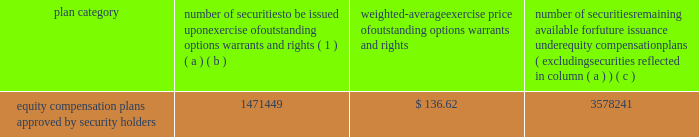Part a0iii item a010 .
Directors , executive officers and corporate governance for the information required by this item a010 with respect to our executive officers , see part a0i , item 1 .
Of this report .
For the other information required by this item a010 , see 201celection of directors , 201d 201cnominees for election to the board of directors , 201d 201ccorporate governance 201d and 201csection a016 ( a ) beneficial ownership reporting compliance , 201d in the proxy statement for our 2019 annual meeting , which information is incorporated herein by reference .
The proxy statement for our 2019 annual meeting will be filed within 120 a0days after the end of the fiscal year covered by this annual report on form 10-k .
Item a011 .
Executive compensation for the information required by this item a011 , see 201ccompensation discussion and analysis , 201d 201ccompensation committee report , 201d and 201cexecutive compensation 201d in the proxy statement for our 2019 annual meeting , which information is incorporated herein by reference .
Item a012 .
Security ownership of certain beneficial owners and management and related stockholder matters for the information required by this item a012 with respect to beneficial ownership of our common stock , see 201csecurity ownership of certain beneficial owners and management 201d in the proxy statement for our 2019 annual meeting , which information is incorporated herein by reference .
The table sets forth certain information as of december a031 , 2018 regarding our equity plans : plan category number of securities to be issued upon exercise of outstanding options , warrants and rights ( 1 ) weighted-average exercise price of outstanding options , warrants and rights number of securities remaining available for future issuance under equity compensation plans ( excluding securities reflected in column ( a ) ( b ) ( c ) equity compensation plans approved by security holders 1471449 $ 136.62 3578241 ( 1 ) the number of securities in column ( a ) include 22290 shares of common stock underlying performance stock units if maximum performance levels are achieved ; the actual number of shares , if any , to be issued with respect to the performance stock units will be based on performance with respect to specified financial and relative stock price measures .
Item a013 .
Certain relationships and related transactions , and director independence for the information required by this item a013 , see 201ccertain transactions 201d and 201ccorporate governance 201d in the proxy statement for our 2019 annual meeting , which information is incorporated herein by reference .
Item a014 .
Principal accounting fees and services for the information required by this item a014 , see 201caudit and non-audit fees 201d and 201caudit committee pre-approval procedures 201d in the proxy statement for our 2019 annual meeting , which information is incorporated herein by reference. .
Part a0iii item a010 .
Directors , executive officers and corporate governance for the information required by this item a010 with respect to our executive officers , see part a0i , item 1 .
Of this report .
For the other information required by this item a010 , see 201celection of directors , 201d 201cnominees for election to the board of directors , 201d 201ccorporate governance 201d and 201csection a016 ( a ) beneficial ownership reporting compliance , 201d in the proxy statement for our 2019 annual meeting , which information is incorporated herein by reference .
The proxy statement for our 2019 annual meeting will be filed within 120 a0days after the end of the fiscal year covered by this annual report on form 10-k .
Item a011 .
Executive compensation for the information required by this item a011 , see 201ccompensation discussion and analysis , 201d 201ccompensation committee report , 201d and 201cexecutive compensation 201d in the proxy statement for our 2019 annual meeting , which information is incorporated herein by reference .
Item a012 .
Security ownership of certain beneficial owners and management and related stockholder matters for the information required by this item a012 with respect to beneficial ownership of our common stock , see 201csecurity ownership of certain beneficial owners and management 201d in the proxy statement for our 2019 annual meeting , which information is incorporated herein by reference .
The following table sets forth certain information as of december a031 , 2018 regarding our equity plans : plan category number of securities to be issued upon exercise of outstanding options , warrants and rights ( 1 ) weighted-average exercise price of outstanding options , warrants and rights number of securities remaining available for future issuance under equity compensation plans ( excluding securities reflected in column ( a ) ( b ) ( c ) equity compensation plans approved by security holders 1471449 $ 136.62 3578241 ( 1 ) the number of securities in column ( a ) include 22290 shares of common stock underlying performance stock units if maximum performance levels are achieved ; the actual number of shares , if any , to be issued with respect to the performance stock units will be based on performance with respect to specified financial and relative stock price measures .
Item a013 .
Certain relationships and related transactions , and director independence for the information required by this item a013 , see 201ccertain transactions 201d and 201ccorporate governance 201d in the proxy statement for our 2019 annual meeting , which information is incorporated herein by reference .
Item a014 .
Principal accounting fees and services for the information required by this item a014 , see 201caudit and non-audit fees 201d and 201caudit committee pre-approval procedures 201d in the proxy statement for our 2019 annual meeting , which information is incorporated herein by reference. .
What percentage of securities to be issued upon exercise are shares of common stock underlying performance stock units if maximum performance levels are achieved? 
Computations: (22290 / 1471449)
Answer: 0.01515. 